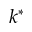Convert formula to latex. <formula><loc_0><loc_0><loc_500><loc_500>k ^ { * }</formula> 